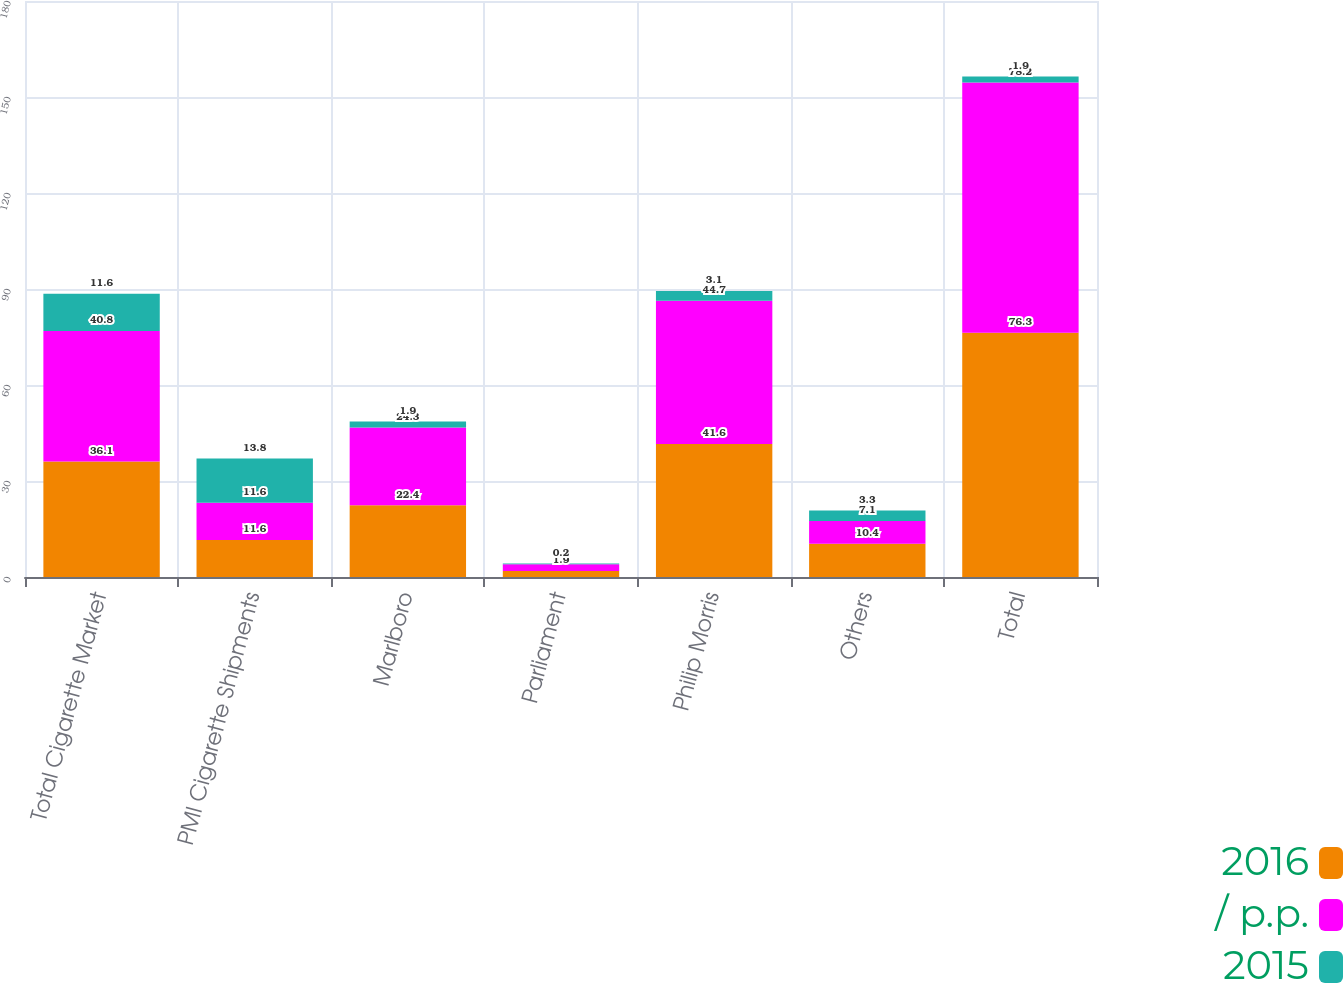Convert chart to OTSL. <chart><loc_0><loc_0><loc_500><loc_500><stacked_bar_chart><ecel><fcel>Total Cigarette Market<fcel>PMI Cigarette Shipments<fcel>Marlboro<fcel>Parliament<fcel>Philip Morris<fcel>Others<fcel>Total<nl><fcel>2016<fcel>36.1<fcel>11.6<fcel>22.4<fcel>1.9<fcel>41.6<fcel>10.4<fcel>76.3<nl><fcel>/ p.p.<fcel>40.8<fcel>11.6<fcel>24.3<fcel>2.1<fcel>44.7<fcel>7.1<fcel>78.2<nl><fcel>2015<fcel>11.6<fcel>13.8<fcel>1.9<fcel>0.2<fcel>3.1<fcel>3.3<fcel>1.9<nl></chart> 